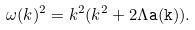<formula> <loc_0><loc_0><loc_500><loc_500>\omega ( k ) ^ { 2 } = k ^ { 2 } ( k ^ { 2 } + 2 \Lambda \tt a ( k ) ) .</formula> 